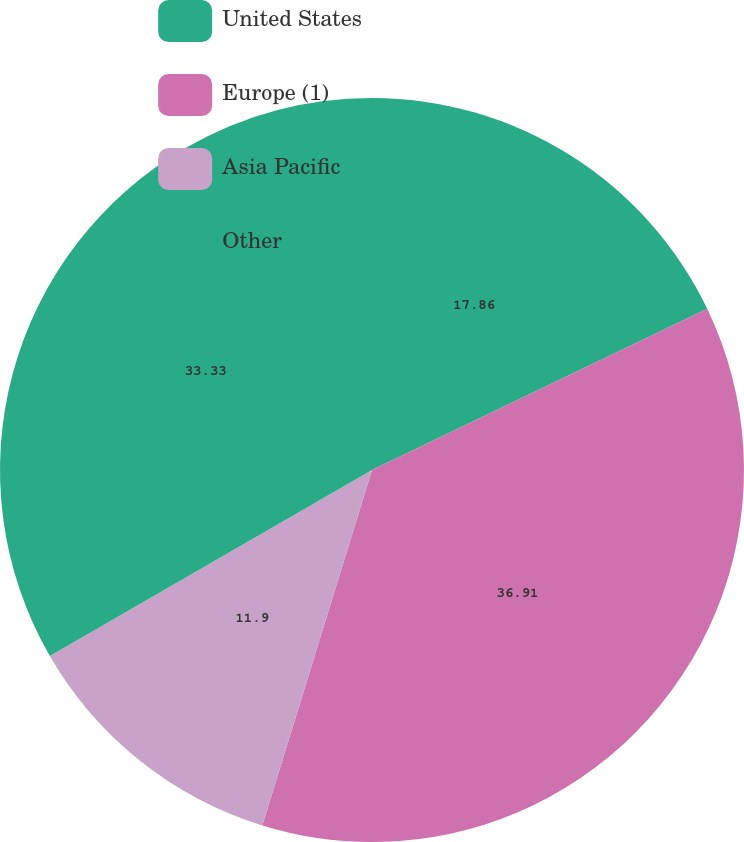Convert chart to OTSL. <chart><loc_0><loc_0><loc_500><loc_500><pie_chart><fcel>United States<fcel>Europe (1)<fcel>Asia Pacific<fcel>Other<nl><fcel>17.86%<fcel>36.9%<fcel>11.9%<fcel>33.33%<nl></chart> 